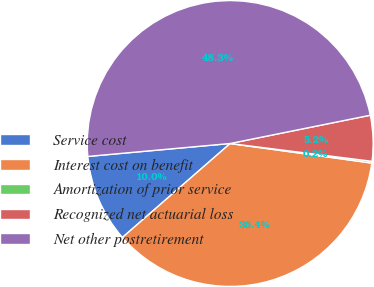<chart> <loc_0><loc_0><loc_500><loc_500><pie_chart><fcel>Service cost<fcel>Interest cost on benefit<fcel>Amortization of prior service<fcel>Recognized net actuarial loss<fcel>Net other postretirement<nl><fcel>9.97%<fcel>36.4%<fcel>0.2%<fcel>5.16%<fcel>48.27%<nl></chart> 